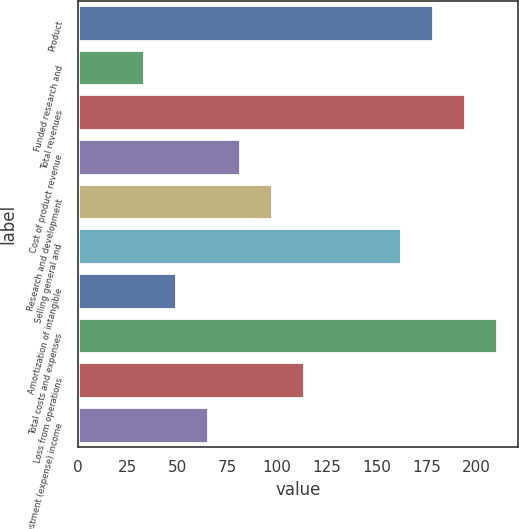Convert chart. <chart><loc_0><loc_0><loc_500><loc_500><bar_chart><fcel>Product<fcel>Funded research and<fcel>Total revenues<fcel>Cost of product revenue<fcel>Research and development<fcel>Selling general and<fcel>Amortization of intangible<fcel>Total costs and expenses<fcel>Loss from operations<fcel>Investment (expense) income<nl><fcel>178<fcel>33.1<fcel>194.1<fcel>81.4<fcel>97.5<fcel>161.9<fcel>49.2<fcel>210.2<fcel>113.6<fcel>65.3<nl></chart> 